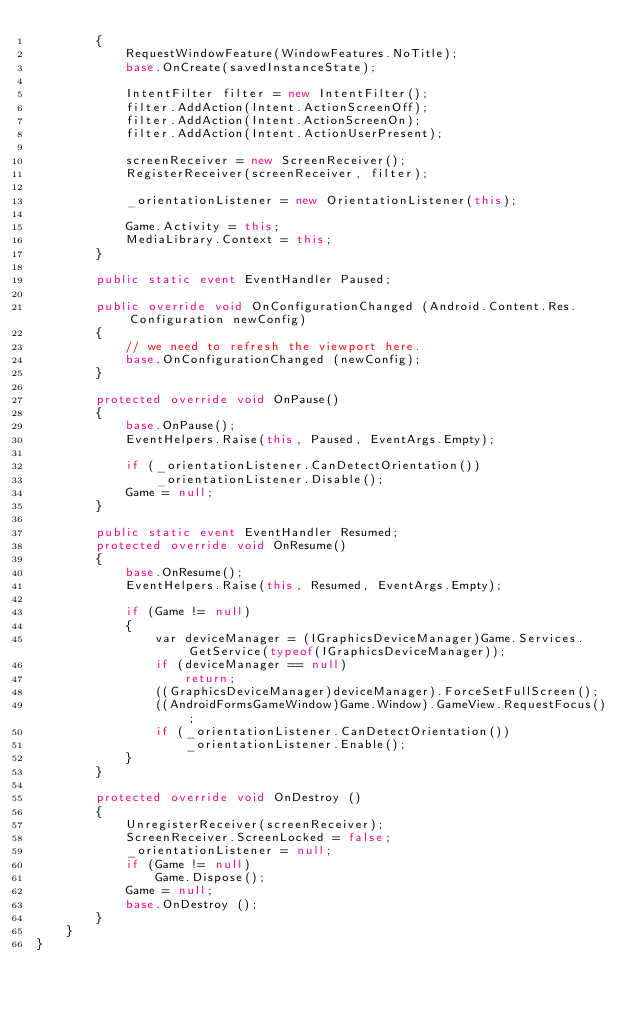<code> <loc_0><loc_0><loc_500><loc_500><_C#_>		{
            RequestWindowFeature(WindowFeatures.NoTitle);
            base.OnCreate(savedInstanceState);

			IntentFilter filter = new IntentFilter();
		    filter.AddAction(Intent.ActionScreenOff);
		    filter.AddAction(Intent.ActionScreenOn);
		    filter.AddAction(Intent.ActionUserPresent);
		    
		    screenReceiver = new ScreenReceiver();
		    RegisterReceiver(screenReceiver, filter);

            _orientationListener = new OrientationListener(this);

			Game.Activity = this;
            MediaLibrary.Context = this;
		}

        public static event EventHandler Paused;

		public override void OnConfigurationChanged (Android.Content.Res.Configuration newConfig)
		{
			// we need to refresh the viewport here.
			base.OnConfigurationChanged (newConfig);
		}

        protected override void OnPause()
        {
            base.OnPause();
            EventHelpers.Raise(this, Paused, EventArgs.Empty);

            if (_orientationListener.CanDetectOrientation())
                _orientationListener.Disable();
            Game = null;
        }

        public static event EventHandler Resumed;
        protected override void OnResume()
        {
            base.OnResume();
            EventHelpers.Raise(this, Resumed, EventArgs.Empty);

            if (Game != null)
            {
                var deviceManager = (IGraphicsDeviceManager)Game.Services.GetService(typeof(IGraphicsDeviceManager));
                if (deviceManager == null)
                    return;
                ((GraphicsDeviceManager)deviceManager).ForceSetFullScreen();
                ((AndroidFormsGameWindow)Game.Window).GameView.RequestFocus();
                if (_orientationListener.CanDetectOrientation())
                    _orientationListener.Enable();
            }
        }

		protected override void OnDestroy ()
		{
            UnregisterReceiver(screenReceiver);
            ScreenReceiver.ScreenLocked = false;
            _orientationListener = null;
            if (Game != null)
                Game.Dispose();
            Game = null;
			base.OnDestroy ();
		}
    }
}
</code> 